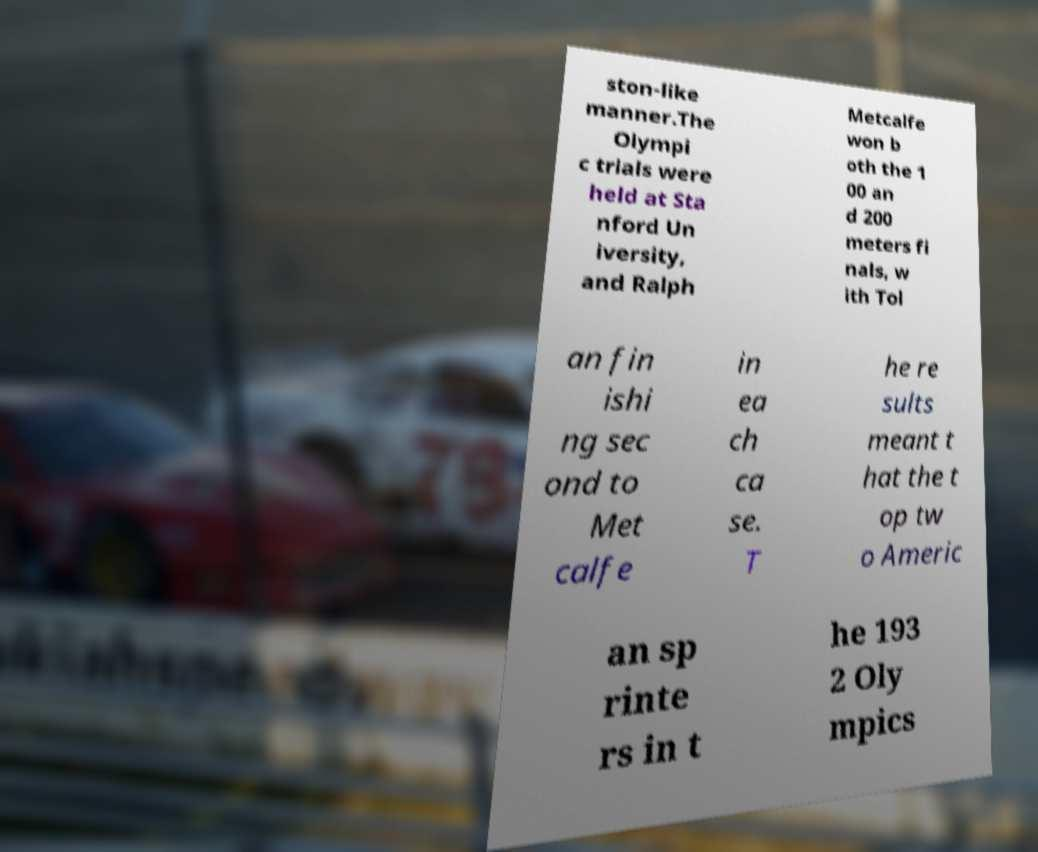For documentation purposes, I need the text within this image transcribed. Could you provide that? ston-like manner.The Olympi c trials were held at Sta nford Un iversity, and Ralph Metcalfe won b oth the 1 00 an d 200 meters fi nals, w ith Tol an fin ishi ng sec ond to Met calfe in ea ch ca se. T he re sults meant t hat the t op tw o Americ an sp rinte rs in t he 193 2 Oly mpics 